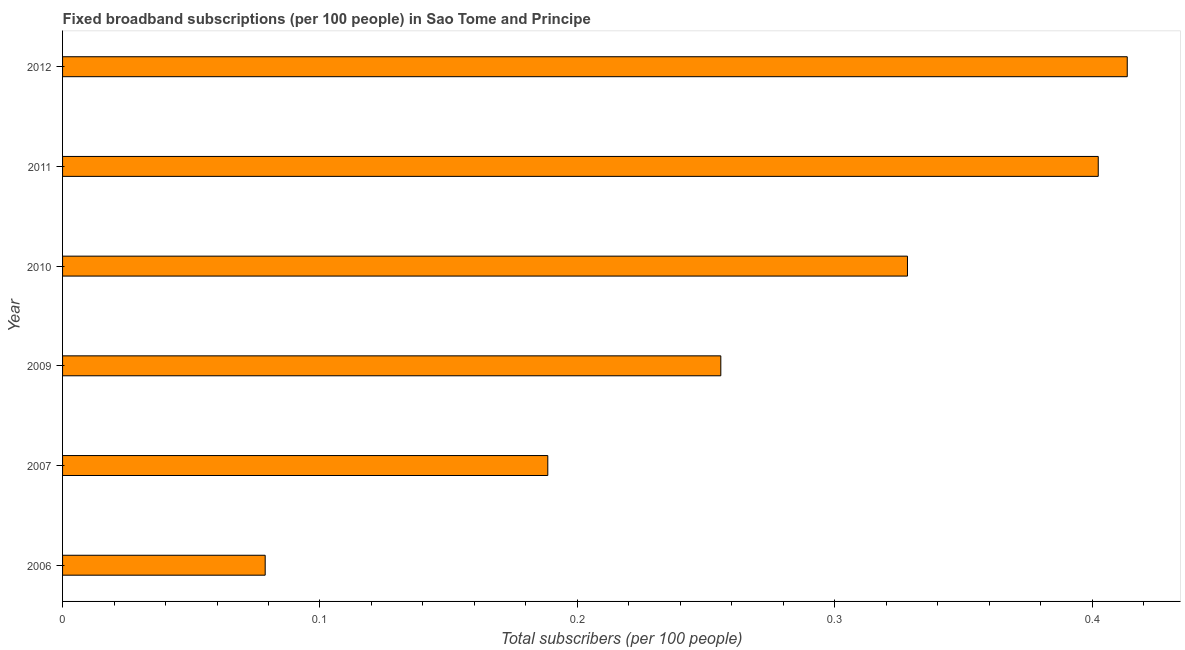Does the graph contain grids?
Give a very brief answer. No. What is the title of the graph?
Make the answer very short. Fixed broadband subscriptions (per 100 people) in Sao Tome and Principe. What is the label or title of the X-axis?
Your response must be concise. Total subscribers (per 100 people). What is the label or title of the Y-axis?
Offer a very short reply. Year. What is the total number of fixed broadband subscriptions in 2011?
Provide a short and direct response. 0.4. Across all years, what is the maximum total number of fixed broadband subscriptions?
Your response must be concise. 0.41. Across all years, what is the minimum total number of fixed broadband subscriptions?
Your response must be concise. 0.08. In which year was the total number of fixed broadband subscriptions maximum?
Keep it short and to the point. 2012. What is the sum of the total number of fixed broadband subscriptions?
Your answer should be compact. 1.67. What is the difference between the total number of fixed broadband subscriptions in 2007 and 2011?
Give a very brief answer. -0.21. What is the average total number of fixed broadband subscriptions per year?
Provide a succinct answer. 0.28. What is the median total number of fixed broadband subscriptions?
Give a very brief answer. 0.29. In how many years, is the total number of fixed broadband subscriptions greater than 0.24 ?
Your answer should be compact. 4. Do a majority of the years between 2006 and 2010 (inclusive) have total number of fixed broadband subscriptions greater than 0.28 ?
Offer a very short reply. No. What is the ratio of the total number of fixed broadband subscriptions in 2009 to that in 2010?
Keep it short and to the point. 0.78. What is the difference between the highest and the second highest total number of fixed broadband subscriptions?
Make the answer very short. 0.01. What is the difference between the highest and the lowest total number of fixed broadband subscriptions?
Your answer should be very brief. 0.33. Are all the bars in the graph horizontal?
Your answer should be compact. Yes. Are the values on the major ticks of X-axis written in scientific E-notation?
Provide a succinct answer. No. What is the Total subscribers (per 100 people) of 2006?
Provide a succinct answer. 0.08. What is the Total subscribers (per 100 people) in 2007?
Your answer should be compact. 0.19. What is the Total subscribers (per 100 people) of 2009?
Your answer should be compact. 0.26. What is the Total subscribers (per 100 people) in 2010?
Give a very brief answer. 0.33. What is the Total subscribers (per 100 people) of 2011?
Give a very brief answer. 0.4. What is the Total subscribers (per 100 people) in 2012?
Your answer should be compact. 0.41. What is the difference between the Total subscribers (per 100 people) in 2006 and 2007?
Your response must be concise. -0.11. What is the difference between the Total subscribers (per 100 people) in 2006 and 2009?
Your answer should be compact. -0.18. What is the difference between the Total subscribers (per 100 people) in 2006 and 2010?
Provide a short and direct response. -0.25. What is the difference between the Total subscribers (per 100 people) in 2006 and 2011?
Provide a succinct answer. -0.32. What is the difference between the Total subscribers (per 100 people) in 2006 and 2012?
Your answer should be compact. -0.33. What is the difference between the Total subscribers (per 100 people) in 2007 and 2009?
Ensure brevity in your answer.  -0.07. What is the difference between the Total subscribers (per 100 people) in 2007 and 2010?
Provide a short and direct response. -0.14. What is the difference between the Total subscribers (per 100 people) in 2007 and 2011?
Offer a very short reply. -0.21. What is the difference between the Total subscribers (per 100 people) in 2007 and 2012?
Provide a succinct answer. -0.23. What is the difference between the Total subscribers (per 100 people) in 2009 and 2010?
Offer a very short reply. -0.07. What is the difference between the Total subscribers (per 100 people) in 2009 and 2011?
Offer a very short reply. -0.15. What is the difference between the Total subscribers (per 100 people) in 2009 and 2012?
Provide a short and direct response. -0.16. What is the difference between the Total subscribers (per 100 people) in 2010 and 2011?
Make the answer very short. -0.07. What is the difference between the Total subscribers (per 100 people) in 2010 and 2012?
Offer a very short reply. -0.09. What is the difference between the Total subscribers (per 100 people) in 2011 and 2012?
Your answer should be very brief. -0.01. What is the ratio of the Total subscribers (per 100 people) in 2006 to that in 2007?
Give a very brief answer. 0.42. What is the ratio of the Total subscribers (per 100 people) in 2006 to that in 2009?
Keep it short and to the point. 0.31. What is the ratio of the Total subscribers (per 100 people) in 2006 to that in 2010?
Your answer should be very brief. 0.24. What is the ratio of the Total subscribers (per 100 people) in 2006 to that in 2011?
Keep it short and to the point. 0.2. What is the ratio of the Total subscribers (per 100 people) in 2006 to that in 2012?
Your response must be concise. 0.19. What is the ratio of the Total subscribers (per 100 people) in 2007 to that in 2009?
Make the answer very short. 0.74. What is the ratio of the Total subscribers (per 100 people) in 2007 to that in 2010?
Your response must be concise. 0.57. What is the ratio of the Total subscribers (per 100 people) in 2007 to that in 2011?
Offer a terse response. 0.47. What is the ratio of the Total subscribers (per 100 people) in 2007 to that in 2012?
Your answer should be compact. 0.46. What is the ratio of the Total subscribers (per 100 people) in 2009 to that in 2010?
Offer a terse response. 0.78. What is the ratio of the Total subscribers (per 100 people) in 2009 to that in 2011?
Your answer should be very brief. 0.64. What is the ratio of the Total subscribers (per 100 people) in 2009 to that in 2012?
Your response must be concise. 0.62. What is the ratio of the Total subscribers (per 100 people) in 2010 to that in 2011?
Offer a very short reply. 0.82. What is the ratio of the Total subscribers (per 100 people) in 2010 to that in 2012?
Give a very brief answer. 0.79. 